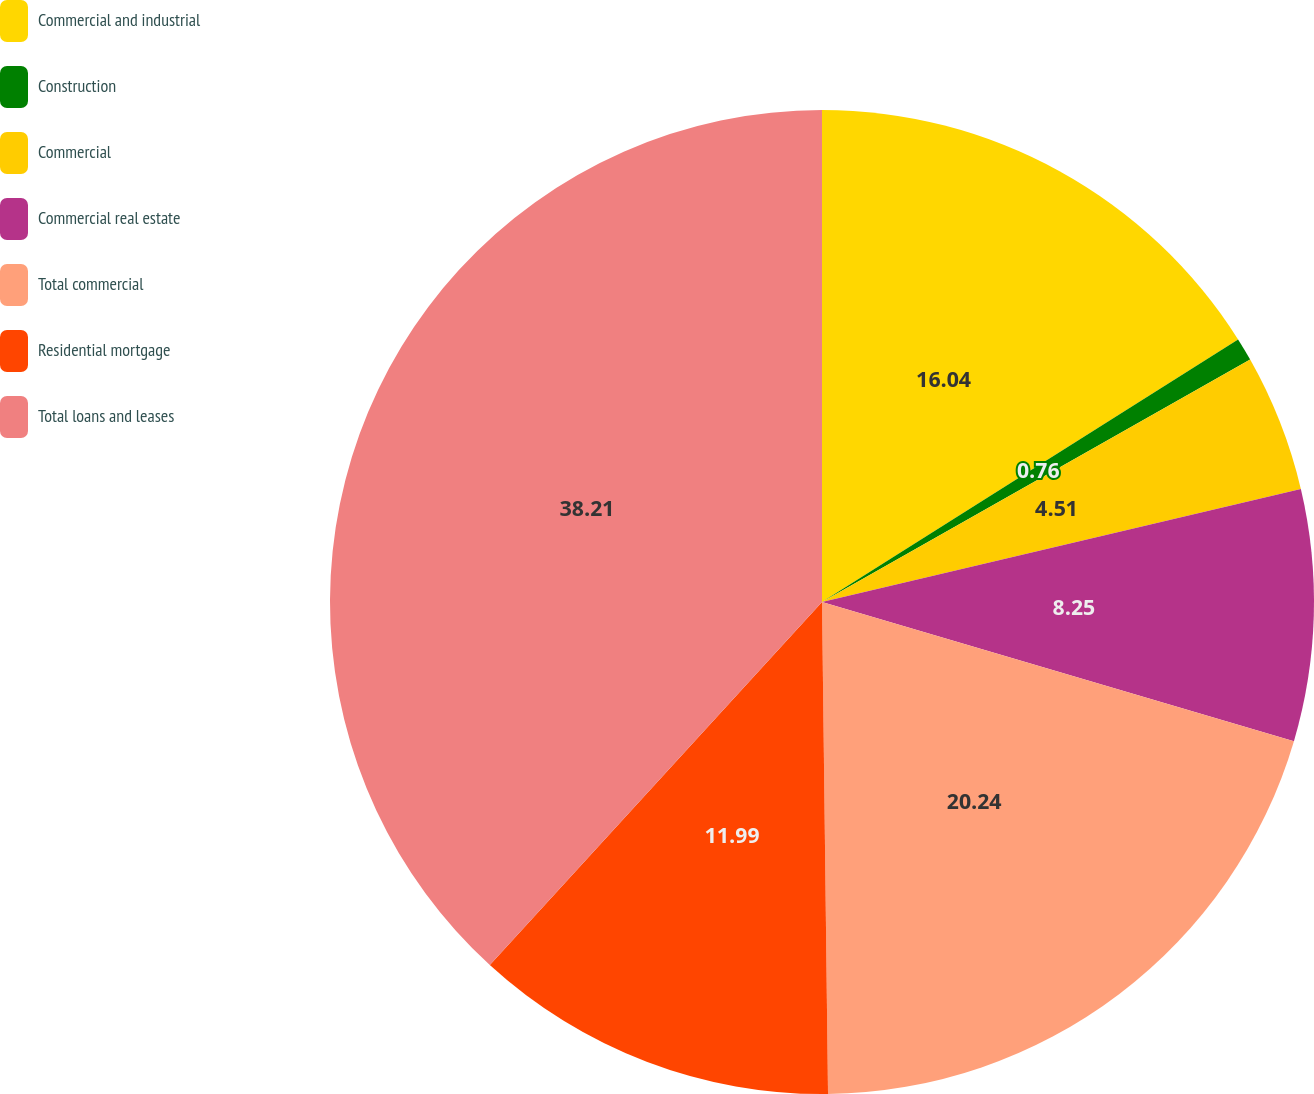Convert chart to OTSL. <chart><loc_0><loc_0><loc_500><loc_500><pie_chart><fcel>Commercial and industrial<fcel>Construction<fcel>Commercial<fcel>Commercial real estate<fcel>Total commercial<fcel>Residential mortgage<fcel>Total loans and leases<nl><fcel>16.04%<fcel>0.76%<fcel>4.51%<fcel>8.25%<fcel>20.24%<fcel>11.99%<fcel>38.2%<nl></chart> 